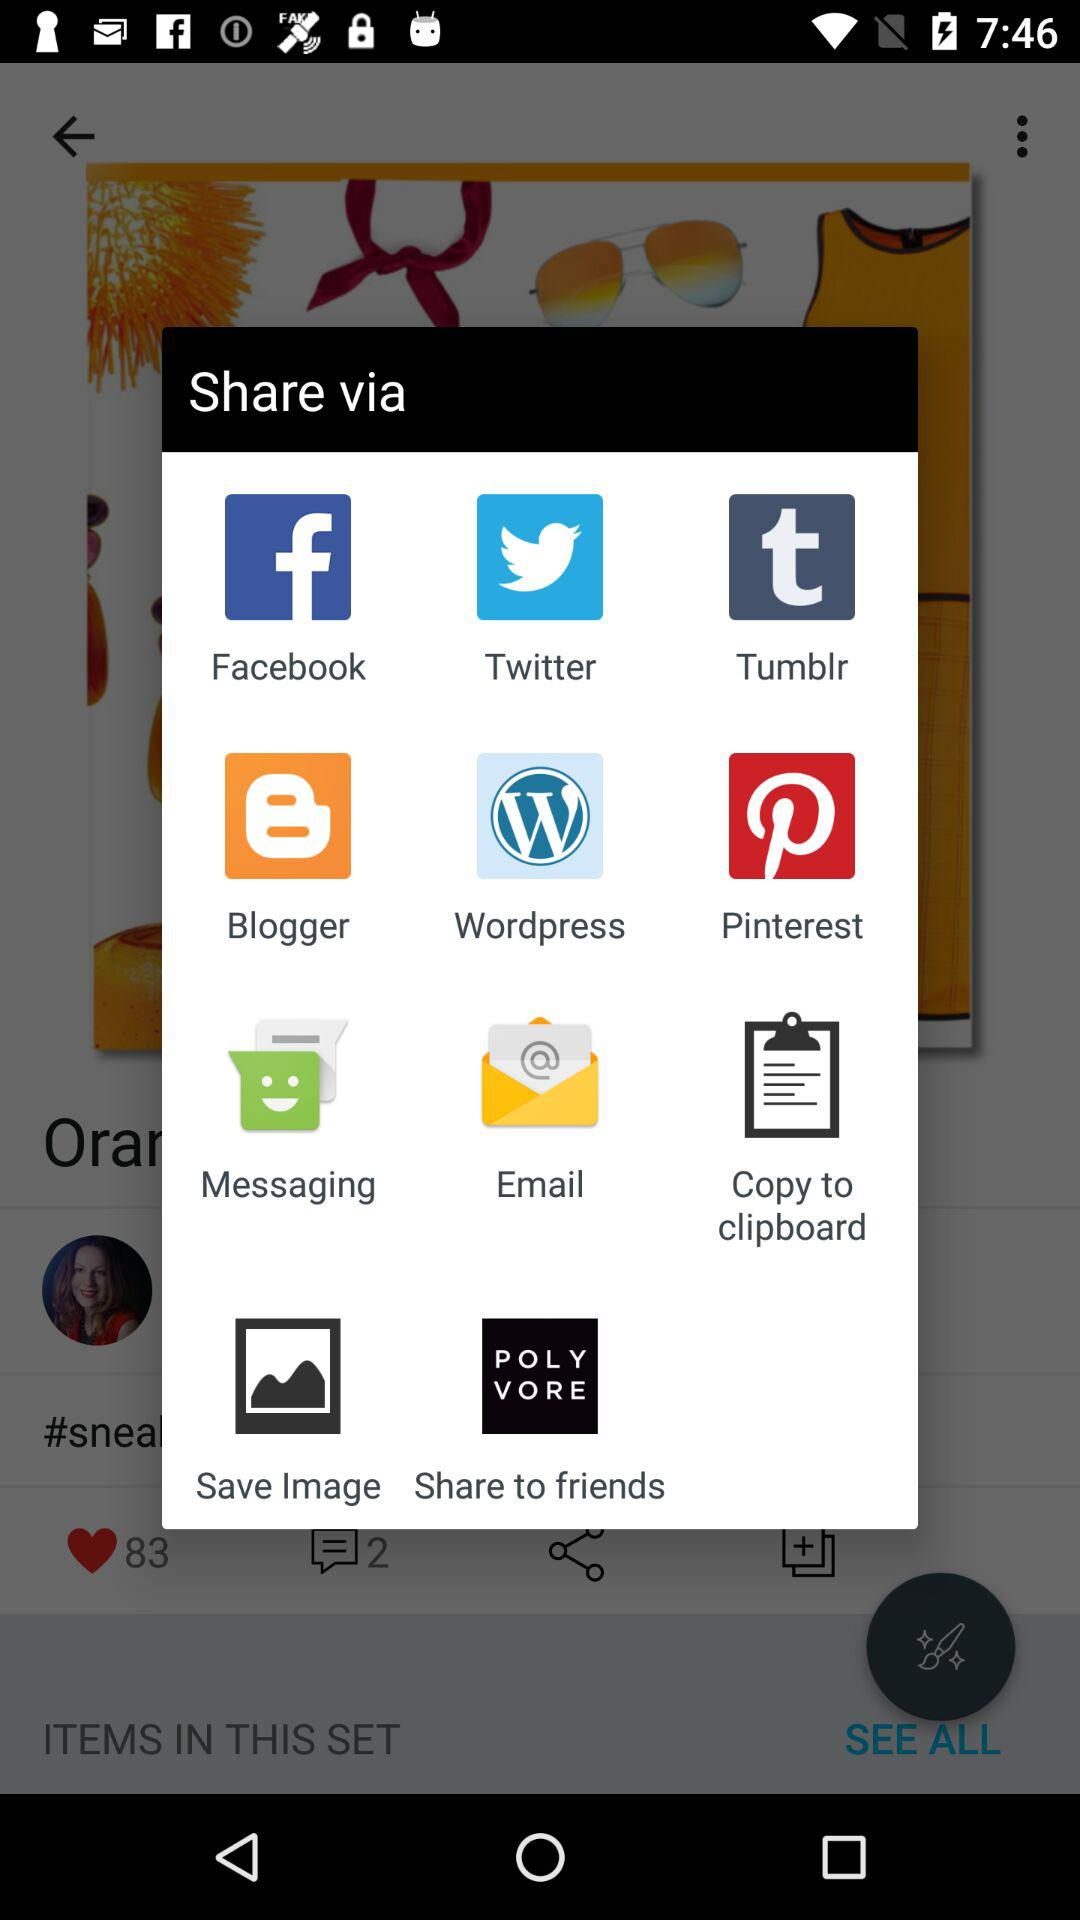Through which applications can we share? You can share through "Facebook", "Twitter", "Tumblr", "Blogger", "Wordpress", "Pinterest", "Messaging", "Email", "Save Image" and "Share to friends". 